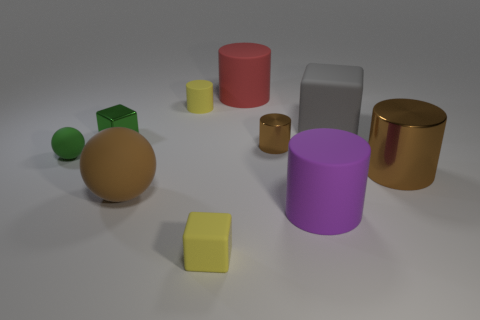What do the different sizes of objects suggest about their potential use? The varied sizes of the objects might imply different functions. The smaller cubes and cylinders could be thought of as containers or building blocks, while the larger cylinders and spheres might serve a more decorative purpose or represent scaled models. 